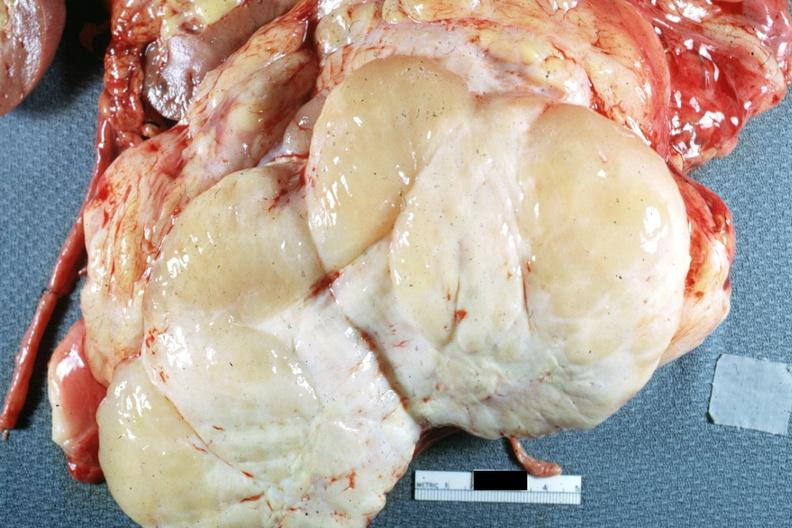what does this image show?
Answer the question using a single word or phrase. Cut surface of lesion natural color typical appearance of a sarcoma fish flesh and yellow areas suggesting of liposarcoma which it was 